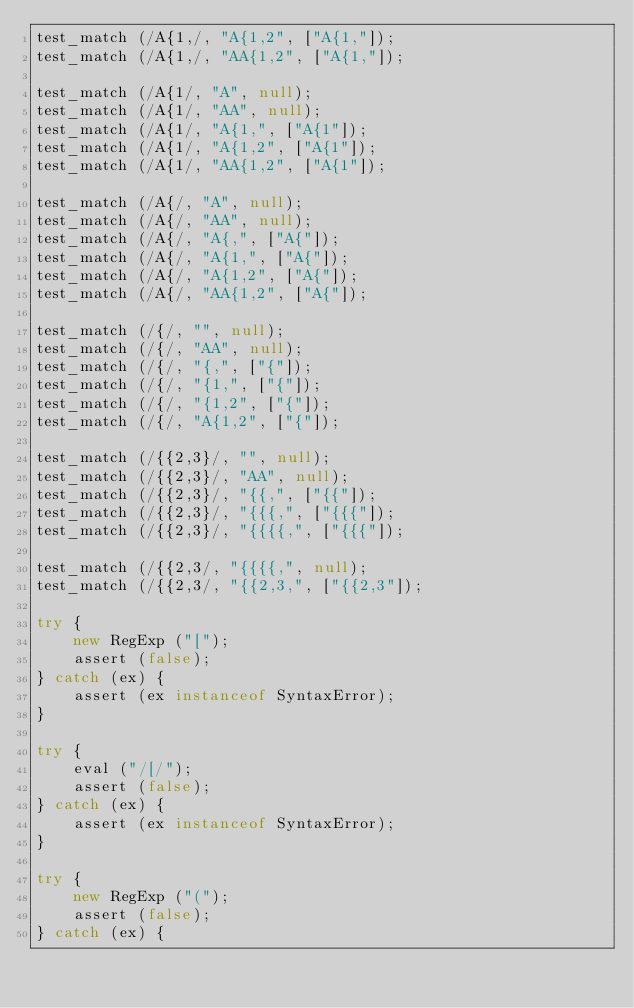<code> <loc_0><loc_0><loc_500><loc_500><_JavaScript_>test_match (/A{1,/, "A{1,2", ["A{1,"]);
test_match (/A{1,/, "AA{1,2", ["A{1,"]);

test_match (/A{1/, "A", null);
test_match (/A{1/, "AA", null);
test_match (/A{1/, "A{1,", ["A{1"]);
test_match (/A{1/, "A{1,2", ["A{1"]);
test_match (/A{1/, "AA{1,2", ["A{1"]);

test_match (/A{/, "A", null);
test_match (/A{/, "AA", null);
test_match (/A{/, "A{,", ["A{"]);
test_match (/A{/, "A{1,", ["A{"]);
test_match (/A{/, "A{1,2", ["A{"]);
test_match (/A{/, "AA{1,2", ["A{"]);

test_match (/{/, "", null);
test_match (/{/, "AA", null);
test_match (/{/, "{,", ["{"]);
test_match (/{/, "{1,", ["{"]);
test_match (/{/, "{1,2", ["{"]);
test_match (/{/, "A{1,2", ["{"]);

test_match (/{{2,3}/, "", null);
test_match (/{{2,3}/, "AA", null);
test_match (/{{2,3}/, "{{,", ["{{"]);
test_match (/{{2,3}/, "{{{,", ["{{{"]);
test_match (/{{2,3}/, "{{{{,", ["{{{"]);

test_match (/{{2,3/, "{{{{,", null);
test_match (/{{2,3/, "{{2,3,", ["{{2,3"]);

try {
    new RegExp ("[");
    assert (false);
} catch (ex) {
    assert (ex instanceof SyntaxError);
}

try {
    eval ("/[/");
    assert (false);
} catch (ex) {
    assert (ex instanceof SyntaxError);
}

try {
    new RegExp ("(");
    assert (false);
} catch (ex) {</code> 